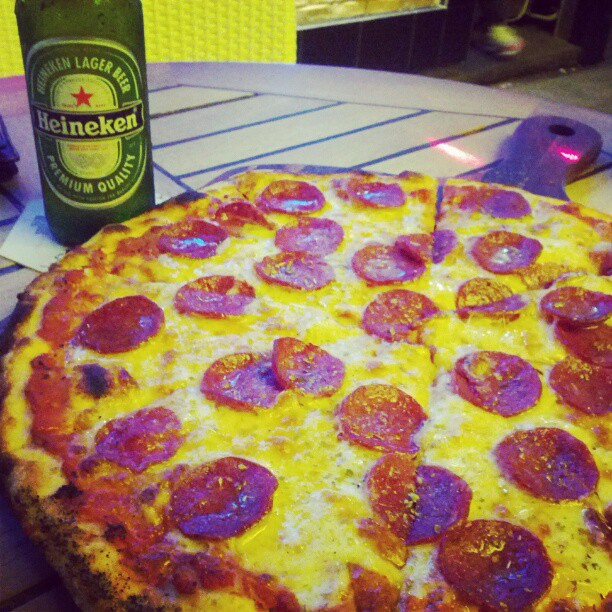Please transcribe the text information in this image. Heineken QUALITY BEER LAGER 